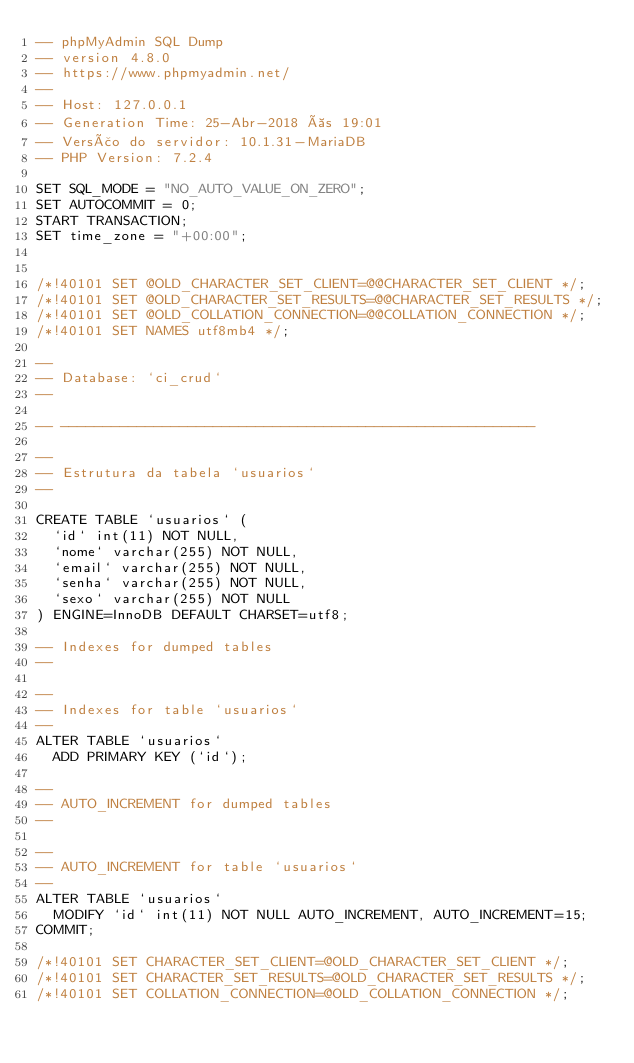Convert code to text. <code><loc_0><loc_0><loc_500><loc_500><_SQL_>-- phpMyAdmin SQL Dump
-- version 4.8.0
-- https://www.phpmyadmin.net/
--
-- Host: 127.0.0.1
-- Generation Time: 25-Abr-2018 às 19:01
-- Versão do servidor: 10.1.31-MariaDB
-- PHP Version: 7.2.4

SET SQL_MODE = "NO_AUTO_VALUE_ON_ZERO";
SET AUTOCOMMIT = 0;
START TRANSACTION;
SET time_zone = "+00:00";


/*!40101 SET @OLD_CHARACTER_SET_CLIENT=@@CHARACTER_SET_CLIENT */;
/*!40101 SET @OLD_CHARACTER_SET_RESULTS=@@CHARACTER_SET_RESULTS */;
/*!40101 SET @OLD_COLLATION_CONNECTION=@@COLLATION_CONNECTION */;
/*!40101 SET NAMES utf8mb4 */;

--
-- Database: `ci_crud`
--

-- --------------------------------------------------------

--
-- Estrutura da tabela `usuarios`
--

CREATE TABLE `usuarios` (
  `id` int(11) NOT NULL,
  `nome` varchar(255) NOT NULL,
  `email` varchar(255) NOT NULL,
  `senha` varchar(255) NOT NULL,
  `sexo` varchar(255) NOT NULL
) ENGINE=InnoDB DEFAULT CHARSET=utf8;

-- Indexes for dumped tables
--

--
-- Indexes for table `usuarios`
--
ALTER TABLE `usuarios`
  ADD PRIMARY KEY (`id`);

--
-- AUTO_INCREMENT for dumped tables
--

--
-- AUTO_INCREMENT for table `usuarios`
--
ALTER TABLE `usuarios`
  MODIFY `id` int(11) NOT NULL AUTO_INCREMENT, AUTO_INCREMENT=15;
COMMIT;

/*!40101 SET CHARACTER_SET_CLIENT=@OLD_CHARACTER_SET_CLIENT */;
/*!40101 SET CHARACTER_SET_RESULTS=@OLD_CHARACTER_SET_RESULTS */;
/*!40101 SET COLLATION_CONNECTION=@OLD_COLLATION_CONNECTION */;
</code> 